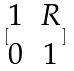Convert formula to latex. <formula><loc_0><loc_0><loc_500><loc_500>[ \begin{matrix} 1 & R \\ 0 & 1 \end{matrix} ]</formula> 